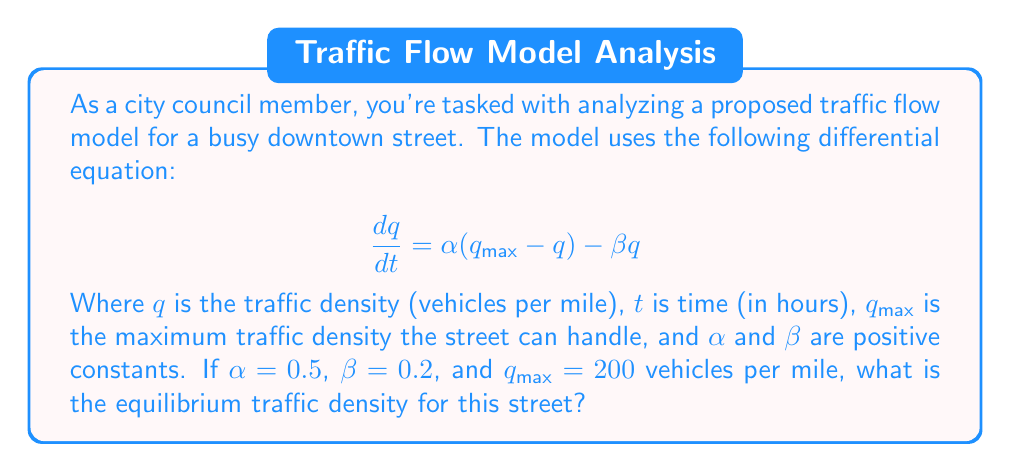Help me with this question. To find the equilibrium traffic density, we need to follow these steps:

1) At equilibrium, the rate of change of traffic density is zero. This means:

   $$\frac{dq}{dt} = 0$$

2) Substituting this into our original equation:

   $$0 = \alpha(q_{max} - q) - \beta q$$

3) Now, let's substitute the given values:
   $\alpha = 0.5$, $\beta = 0.2$, and $q_{max} = 200$

   $$0 = 0.5(200 - q) - 0.2q$$

4) Expand the brackets:

   $$0 = 100 - 0.5q - 0.2q$$

5) Combine like terms:

   $$0 = 100 - 0.7q$$

6) Add 0.7q to both sides:

   $$0.7q = 100$$

7) Divide both sides by 0.7:

   $$q = \frac{100}{0.7} \approx 142.86$$

Therefore, the equilibrium traffic density is approximately 142.86 vehicles per mile.
Answer: 142.86 vehicles per mile 